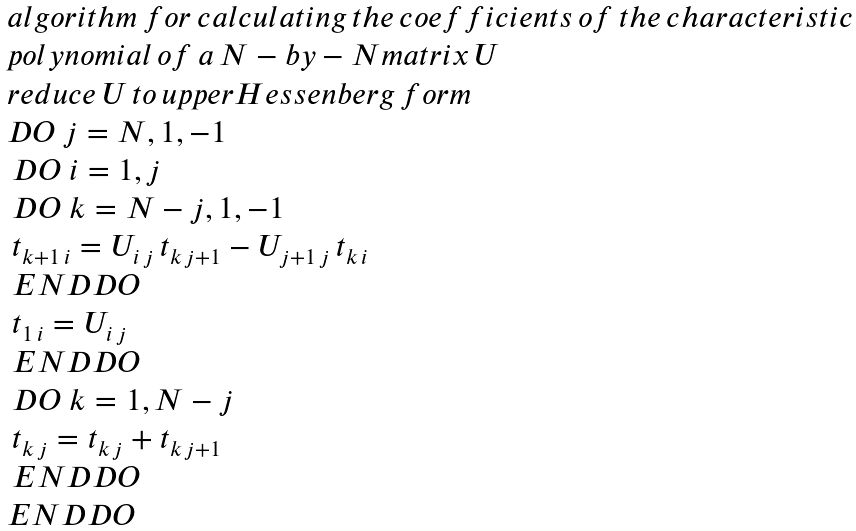Convert formula to latex. <formula><loc_0><loc_0><loc_500><loc_500>\begin{array} { l } { a l g o r i t h m \, f o r \, c a l c u l a t i n g \, t h e \, c o e f f i c i e n t s \, o f \, t h e \, c h a r a c t e r i s t i c } \\ { p o l y n o m i a l \, o f \, a \, N - b y - N m a t r i x \, U } \\ r e d u c e \, U \, t o \, u p p e r H e s s e n b e r g \, f o r m \\ D O \ j = N , 1 , - 1 \\ \, D O \ i = 1 , j \\ \, D O \ k = N - j , 1 , - 1 \\ \, t _ { k + 1 \, i } = U _ { i \, j } \, t _ { k \, j + 1 } - U _ { j + 1 \, j } \, t _ { k \, i } \\ \, E N D D O \\ \, t _ { 1 \, i } = U _ { i \, j } \\ \, E N D D O \\ \, D O \ k = 1 , N - j \\ \, t _ { k \, j } = t _ { k \, j } + t _ { k \, j + 1 } \\ \, E N D D O \\ E N D D O \end{array}</formula> 